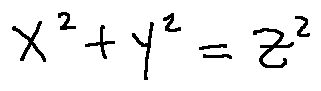<formula> <loc_0><loc_0><loc_500><loc_500>x ^ { 2 } + y ^ { 2 } = z ^ { 2 }</formula> 